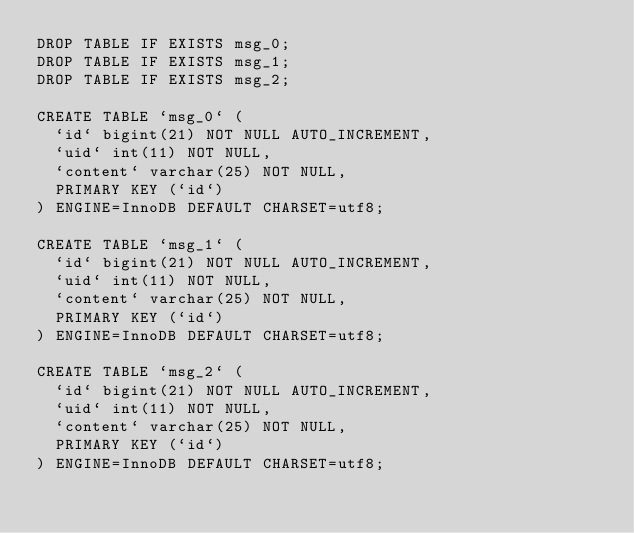Convert code to text. <code><loc_0><loc_0><loc_500><loc_500><_SQL_>DROP TABLE IF EXISTS msg_0;
DROP TABLE IF EXISTS msg_1;
DROP TABLE IF EXISTS msg_2;

CREATE TABLE `msg_0` (
  `id` bigint(21) NOT NULL AUTO_INCREMENT,
  `uid` int(11) NOT NULL,
  `content` varchar(25) NOT NULL,
  PRIMARY KEY (`id`)
) ENGINE=InnoDB DEFAULT CHARSET=utf8;

CREATE TABLE `msg_1` (
  `id` bigint(21) NOT NULL AUTO_INCREMENT,
  `uid` int(11) NOT NULL,
  `content` varchar(25) NOT NULL,
  PRIMARY KEY (`id`)
) ENGINE=InnoDB DEFAULT CHARSET=utf8;

CREATE TABLE `msg_2` (
  `id` bigint(21) NOT NULL AUTO_INCREMENT,
  `uid` int(11) NOT NULL,
  `content` varchar(25) NOT NULL,
  PRIMARY KEY (`id`)
) ENGINE=InnoDB DEFAULT CHARSET=utf8;
</code> 